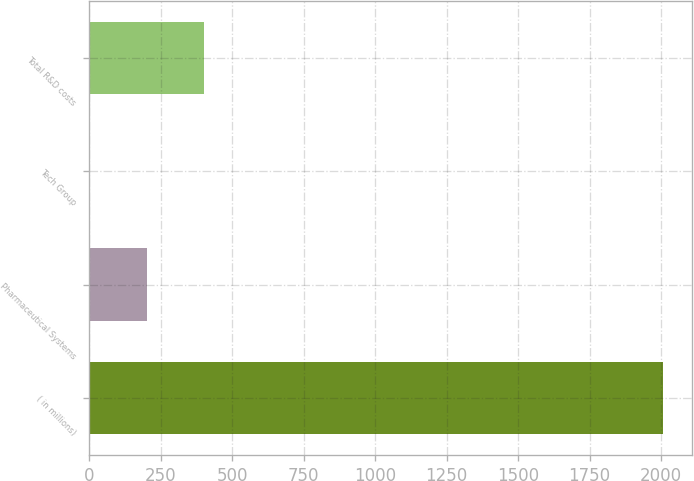<chart> <loc_0><loc_0><loc_500><loc_500><bar_chart><fcel>( in millions)<fcel>Pharmaceutical Systems<fcel>Tech Group<fcel>Total R&D costs<nl><fcel>2007<fcel>202.59<fcel>2.1<fcel>403.08<nl></chart> 